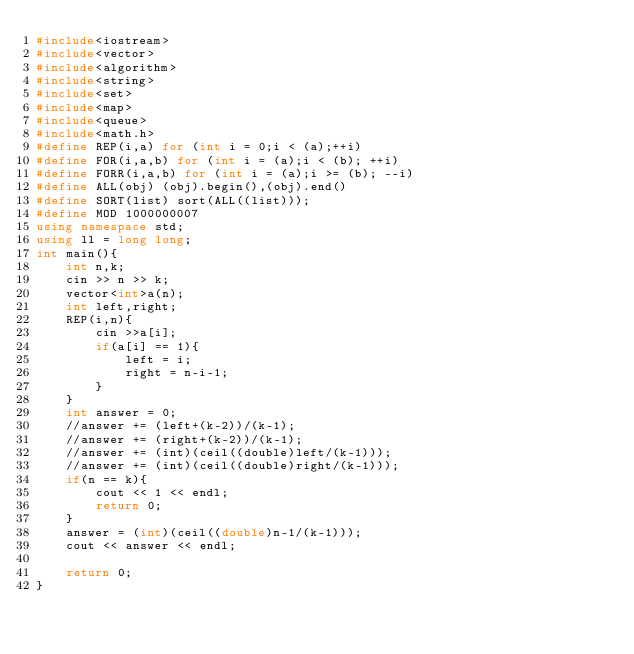<code> <loc_0><loc_0><loc_500><loc_500><_C++_>#include<iostream>
#include<vector>
#include<algorithm>
#include<string>
#include<set>
#include<map>
#include<queue>
#include<math.h>
#define REP(i,a) for (int i = 0;i < (a);++i)
#define FOR(i,a,b) for (int i = (a);i < (b); ++i)
#define FORR(i,a,b) for (int i = (a);i >= (b); --i)
#define ALL(obj) (obj).begin(),(obj).end()
#define SORT(list) sort(ALL((list)));
#define MOD 1000000007
using namespace std;
using ll = long long;
int main(){
    int n,k;
    cin >> n >> k;
    vector<int>a(n);
    int left,right;
    REP(i,n){
        cin >>a[i];
        if(a[i] == 1){
            left = i;
            right = n-i-1;
        }
    }
    int answer = 0;
    //answer += (left+(k-2))/(k-1);
    //answer += (right+(k-2))/(k-1);
    //answer += (int)(ceil((double)left/(k-1)));
    //answer += (int)(ceil((double)right/(k-1)));
    if(n == k){
        cout << 1 << endl;
        return 0;
    }
    answer = (int)(ceil((double)n-1/(k-1)));
    cout << answer << endl;

    return 0;
}</code> 